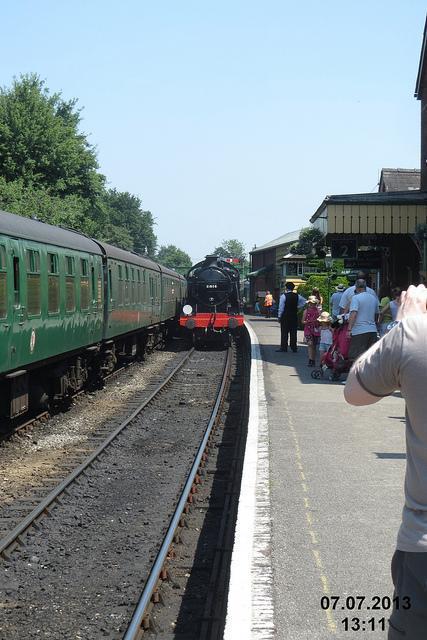How many days after the Independence Day was this picture taken?
Indicate the correct response by choosing from the four available options to answer the question.
Options: Three, one, two, seven. Three. 